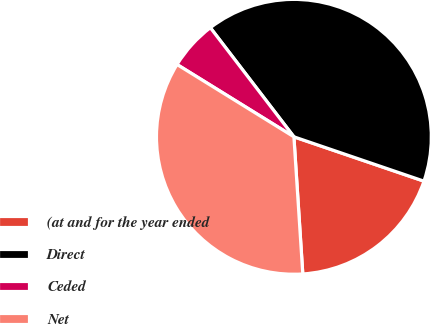Convert chart. <chart><loc_0><loc_0><loc_500><loc_500><pie_chart><fcel>(at and for the year ended<fcel>Direct<fcel>Ceded<fcel>Net<nl><fcel>18.74%<fcel>40.63%<fcel>5.78%<fcel>34.85%<nl></chart> 